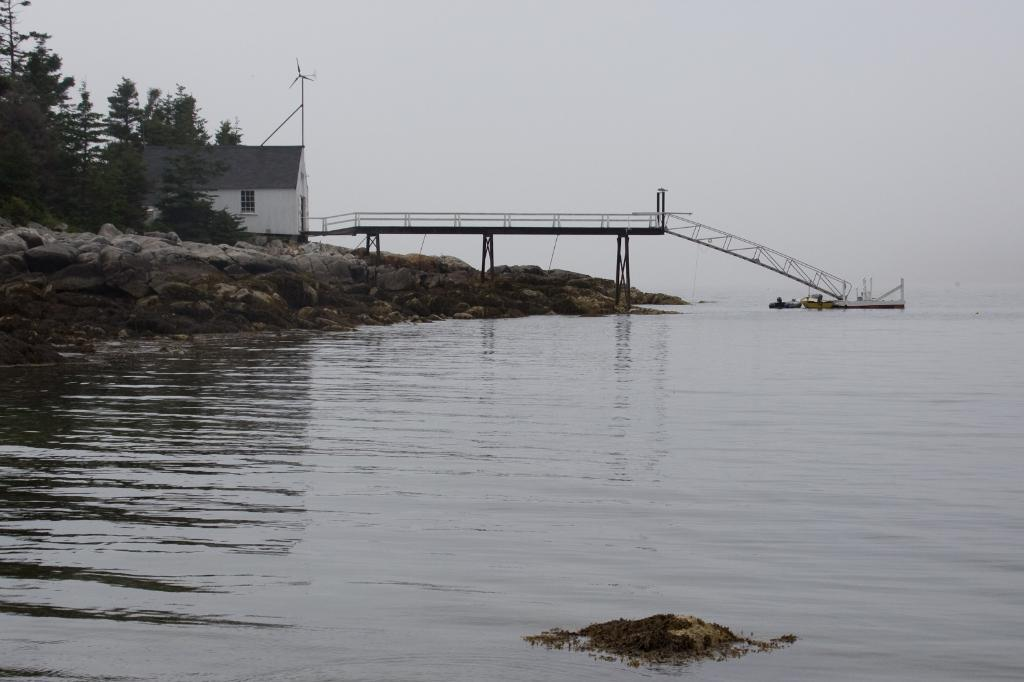What type of natural feature is at the bottom of the image? There is a river at the bottom of the image. What structure is located on the left side of the image? There is a shed on the left side of the image. What type of vegetation is on the left side of the image? There are trees on the left side of the image. What connects the two sides of the river in the image? There is a bridge in the center of the image. What is visible in the background of the image? The sky is visible in the background of the image. What type of lip can be seen on the bridge in the image? There is no lip present on the bridge in the image. What type of seed is growing on the trees in the image? There is no information about seeds growing on the trees in the image. 